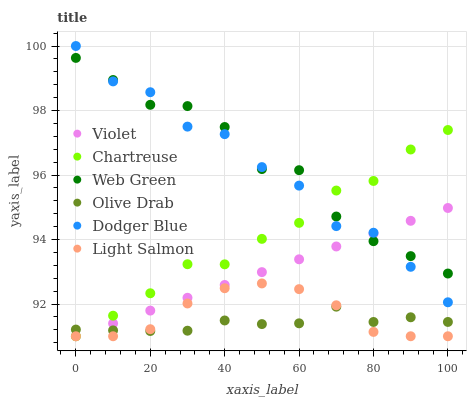Does Olive Drab have the minimum area under the curve?
Answer yes or no. Yes. Does Web Green have the maximum area under the curve?
Answer yes or no. Yes. Does Chartreuse have the minimum area under the curve?
Answer yes or no. No. Does Chartreuse have the maximum area under the curve?
Answer yes or no. No. Is Violet the smoothest?
Answer yes or no. Yes. Is Dodger Blue the roughest?
Answer yes or no. Yes. Is Web Green the smoothest?
Answer yes or no. No. Is Web Green the roughest?
Answer yes or no. No. Does Light Salmon have the lowest value?
Answer yes or no. Yes. Does Web Green have the lowest value?
Answer yes or no. No. Does Dodger Blue have the highest value?
Answer yes or no. Yes. Does Web Green have the highest value?
Answer yes or no. No. Is Light Salmon less than Web Green?
Answer yes or no. Yes. Is Dodger Blue greater than Olive Drab?
Answer yes or no. Yes. Does Olive Drab intersect Chartreuse?
Answer yes or no. Yes. Is Olive Drab less than Chartreuse?
Answer yes or no. No. Is Olive Drab greater than Chartreuse?
Answer yes or no. No. Does Light Salmon intersect Web Green?
Answer yes or no. No. 